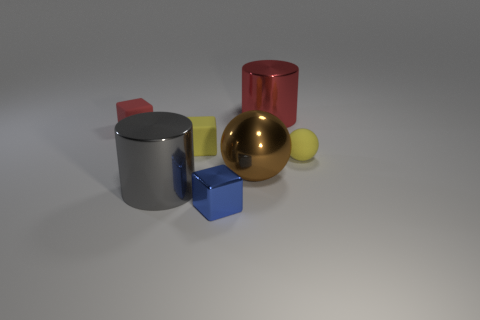What number of objects have the same color as the tiny sphere?
Give a very brief answer. 1. Is the size of the metal ball the same as the red cylinder?
Make the answer very short. Yes. There is a red thing that is the same shape as the small blue thing; what is its size?
Your answer should be compact. Small. The tiny block that is in front of the yellow object that is in front of the tiny yellow matte block is made of what material?
Ensure brevity in your answer.  Metal. Is the big red metal object the same shape as the brown metallic thing?
Provide a short and direct response. No. What number of tiny things are both on the left side of the small ball and to the right of the big gray cylinder?
Provide a succinct answer. 2. Are there an equal number of tiny blue objects that are left of the blue block and blue metallic objects behind the small yellow rubber block?
Make the answer very short. Yes. There is a block that is behind the small yellow rubber block; is it the same size as the yellow thing that is right of the big red object?
Offer a very short reply. Yes. What is the object that is both in front of the red cube and to the left of the yellow matte block made of?
Offer a very short reply. Metal. Is the number of small red metallic cylinders less than the number of tiny rubber objects?
Provide a short and direct response. Yes. 